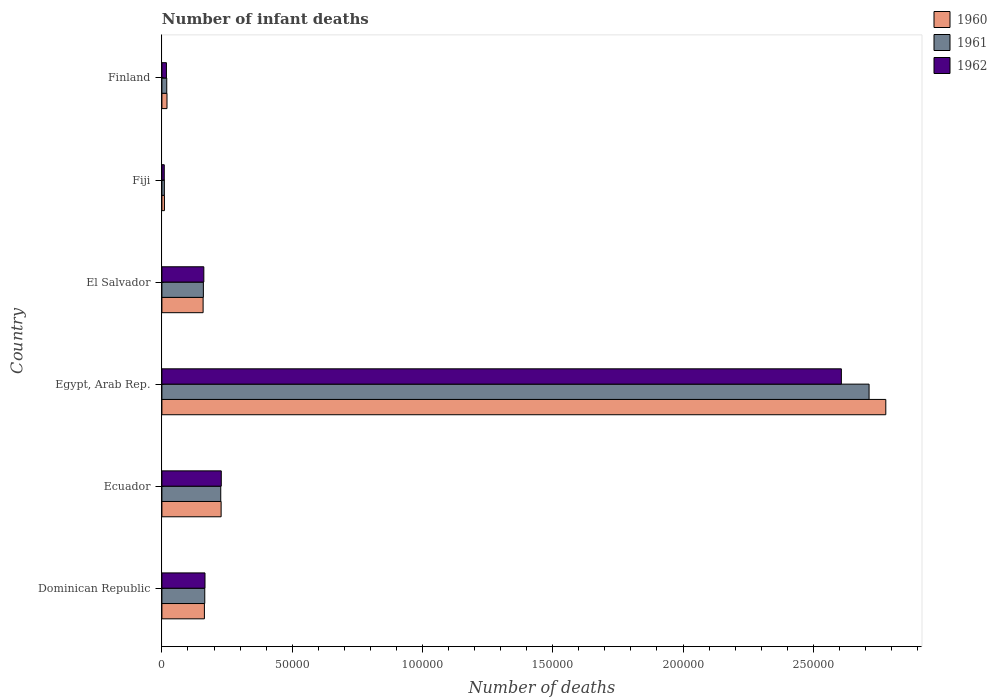How many groups of bars are there?
Provide a succinct answer. 6. Are the number of bars per tick equal to the number of legend labels?
Ensure brevity in your answer.  Yes. Are the number of bars on each tick of the Y-axis equal?
Provide a short and direct response. Yes. In how many cases, is the number of bars for a given country not equal to the number of legend labels?
Offer a very short reply. 0. What is the number of infant deaths in 1962 in El Salvador?
Your answer should be very brief. 1.61e+04. Across all countries, what is the maximum number of infant deaths in 1961?
Offer a terse response. 2.71e+05. Across all countries, what is the minimum number of infant deaths in 1961?
Make the answer very short. 945. In which country was the number of infant deaths in 1962 maximum?
Give a very brief answer. Egypt, Arab Rep. In which country was the number of infant deaths in 1962 minimum?
Make the answer very short. Fiji. What is the total number of infant deaths in 1960 in the graph?
Your answer should be compact. 3.36e+05. What is the difference between the number of infant deaths in 1961 in Ecuador and that in Egypt, Arab Rep.?
Offer a very short reply. -2.49e+05. What is the difference between the number of infant deaths in 1961 in Fiji and the number of infant deaths in 1962 in Finland?
Give a very brief answer. -799. What is the average number of infant deaths in 1962 per country?
Provide a succinct answer. 5.31e+04. What is the difference between the number of infant deaths in 1961 and number of infant deaths in 1960 in Ecuador?
Your answer should be very brief. -143. In how many countries, is the number of infant deaths in 1962 greater than 140000 ?
Make the answer very short. 1. What is the ratio of the number of infant deaths in 1962 in Dominican Republic to that in Fiji?
Offer a very short reply. 18.19. Is the difference between the number of infant deaths in 1961 in Fiji and Finland greater than the difference between the number of infant deaths in 1960 in Fiji and Finland?
Provide a succinct answer. Yes. What is the difference between the highest and the second highest number of infant deaths in 1961?
Provide a short and direct response. 2.49e+05. What is the difference between the highest and the lowest number of infant deaths in 1960?
Provide a short and direct response. 2.77e+05. In how many countries, is the number of infant deaths in 1960 greater than the average number of infant deaths in 1960 taken over all countries?
Your answer should be compact. 1. What does the 3rd bar from the top in Ecuador represents?
Your answer should be compact. 1960. What does the 1st bar from the bottom in Finland represents?
Give a very brief answer. 1960. How many bars are there?
Keep it short and to the point. 18. Are all the bars in the graph horizontal?
Offer a terse response. Yes. How many countries are there in the graph?
Keep it short and to the point. 6. What is the difference between two consecutive major ticks on the X-axis?
Give a very brief answer. 5.00e+04. Does the graph contain any zero values?
Offer a very short reply. No. Does the graph contain grids?
Give a very brief answer. No. How many legend labels are there?
Keep it short and to the point. 3. How are the legend labels stacked?
Ensure brevity in your answer.  Vertical. What is the title of the graph?
Offer a terse response. Number of infant deaths. Does "2004" appear as one of the legend labels in the graph?
Your answer should be very brief. No. What is the label or title of the X-axis?
Give a very brief answer. Number of deaths. What is the Number of deaths of 1960 in Dominican Republic?
Offer a very short reply. 1.63e+04. What is the Number of deaths in 1961 in Dominican Republic?
Your response must be concise. 1.65e+04. What is the Number of deaths of 1962 in Dominican Republic?
Your answer should be compact. 1.65e+04. What is the Number of deaths of 1960 in Ecuador?
Give a very brief answer. 2.27e+04. What is the Number of deaths in 1961 in Ecuador?
Make the answer very short. 2.26e+04. What is the Number of deaths in 1962 in Ecuador?
Ensure brevity in your answer.  2.28e+04. What is the Number of deaths of 1960 in Egypt, Arab Rep.?
Make the answer very short. 2.78e+05. What is the Number of deaths of 1961 in Egypt, Arab Rep.?
Offer a very short reply. 2.71e+05. What is the Number of deaths in 1962 in Egypt, Arab Rep.?
Make the answer very short. 2.61e+05. What is the Number of deaths of 1960 in El Salvador?
Make the answer very short. 1.58e+04. What is the Number of deaths in 1961 in El Salvador?
Ensure brevity in your answer.  1.59e+04. What is the Number of deaths in 1962 in El Salvador?
Offer a terse response. 1.61e+04. What is the Number of deaths of 1960 in Fiji?
Your answer should be very brief. 977. What is the Number of deaths of 1961 in Fiji?
Offer a terse response. 945. What is the Number of deaths of 1962 in Fiji?
Keep it short and to the point. 909. What is the Number of deaths of 1960 in Finland?
Give a very brief answer. 1955. What is the Number of deaths of 1961 in Finland?
Ensure brevity in your answer.  1863. What is the Number of deaths in 1962 in Finland?
Your answer should be very brief. 1744. Across all countries, what is the maximum Number of deaths in 1960?
Ensure brevity in your answer.  2.78e+05. Across all countries, what is the maximum Number of deaths of 1961?
Provide a succinct answer. 2.71e+05. Across all countries, what is the maximum Number of deaths in 1962?
Your response must be concise. 2.61e+05. Across all countries, what is the minimum Number of deaths in 1960?
Make the answer very short. 977. Across all countries, what is the minimum Number of deaths in 1961?
Your answer should be very brief. 945. Across all countries, what is the minimum Number of deaths in 1962?
Offer a very short reply. 909. What is the total Number of deaths in 1960 in the graph?
Your answer should be compact. 3.36e+05. What is the total Number of deaths of 1961 in the graph?
Make the answer very short. 3.29e+05. What is the total Number of deaths in 1962 in the graph?
Provide a short and direct response. 3.19e+05. What is the difference between the Number of deaths in 1960 in Dominican Republic and that in Ecuador?
Your response must be concise. -6416. What is the difference between the Number of deaths in 1961 in Dominican Republic and that in Ecuador?
Your answer should be compact. -6135. What is the difference between the Number of deaths of 1962 in Dominican Republic and that in Ecuador?
Your response must be concise. -6251. What is the difference between the Number of deaths of 1960 in Dominican Republic and that in Egypt, Arab Rep.?
Make the answer very short. -2.62e+05. What is the difference between the Number of deaths of 1961 in Dominican Republic and that in Egypt, Arab Rep.?
Give a very brief answer. -2.55e+05. What is the difference between the Number of deaths of 1962 in Dominican Republic and that in Egypt, Arab Rep.?
Give a very brief answer. -2.44e+05. What is the difference between the Number of deaths of 1960 in Dominican Republic and that in El Salvador?
Make the answer very short. 496. What is the difference between the Number of deaths in 1961 in Dominican Republic and that in El Salvador?
Ensure brevity in your answer.  537. What is the difference between the Number of deaths of 1962 in Dominican Republic and that in El Salvador?
Offer a very short reply. 449. What is the difference between the Number of deaths of 1960 in Dominican Republic and that in Fiji?
Offer a terse response. 1.53e+04. What is the difference between the Number of deaths of 1961 in Dominican Republic and that in Fiji?
Make the answer very short. 1.55e+04. What is the difference between the Number of deaths of 1962 in Dominican Republic and that in Fiji?
Your answer should be very brief. 1.56e+04. What is the difference between the Number of deaths in 1960 in Dominican Republic and that in Finland?
Provide a succinct answer. 1.44e+04. What is the difference between the Number of deaths of 1961 in Dominican Republic and that in Finland?
Offer a very short reply. 1.46e+04. What is the difference between the Number of deaths of 1962 in Dominican Republic and that in Finland?
Your response must be concise. 1.48e+04. What is the difference between the Number of deaths in 1960 in Ecuador and that in Egypt, Arab Rep.?
Give a very brief answer. -2.55e+05. What is the difference between the Number of deaths in 1961 in Ecuador and that in Egypt, Arab Rep.?
Keep it short and to the point. -2.49e+05. What is the difference between the Number of deaths of 1962 in Ecuador and that in Egypt, Arab Rep.?
Your answer should be very brief. -2.38e+05. What is the difference between the Number of deaths in 1960 in Ecuador and that in El Salvador?
Your response must be concise. 6912. What is the difference between the Number of deaths of 1961 in Ecuador and that in El Salvador?
Your answer should be very brief. 6672. What is the difference between the Number of deaths of 1962 in Ecuador and that in El Salvador?
Your response must be concise. 6700. What is the difference between the Number of deaths of 1960 in Ecuador and that in Fiji?
Your answer should be very brief. 2.18e+04. What is the difference between the Number of deaths in 1961 in Ecuador and that in Fiji?
Your response must be concise. 2.16e+04. What is the difference between the Number of deaths in 1962 in Ecuador and that in Fiji?
Give a very brief answer. 2.19e+04. What is the difference between the Number of deaths of 1960 in Ecuador and that in Finland?
Offer a terse response. 2.08e+04. What is the difference between the Number of deaths in 1961 in Ecuador and that in Finland?
Keep it short and to the point. 2.07e+04. What is the difference between the Number of deaths in 1962 in Ecuador and that in Finland?
Give a very brief answer. 2.10e+04. What is the difference between the Number of deaths in 1960 in Egypt, Arab Rep. and that in El Salvador?
Offer a terse response. 2.62e+05. What is the difference between the Number of deaths in 1961 in Egypt, Arab Rep. and that in El Salvador?
Provide a short and direct response. 2.56e+05. What is the difference between the Number of deaths in 1962 in Egypt, Arab Rep. and that in El Salvador?
Your answer should be compact. 2.45e+05. What is the difference between the Number of deaths of 1960 in Egypt, Arab Rep. and that in Fiji?
Provide a short and direct response. 2.77e+05. What is the difference between the Number of deaths in 1961 in Egypt, Arab Rep. and that in Fiji?
Make the answer very short. 2.70e+05. What is the difference between the Number of deaths in 1962 in Egypt, Arab Rep. and that in Fiji?
Give a very brief answer. 2.60e+05. What is the difference between the Number of deaths of 1960 in Egypt, Arab Rep. and that in Finland?
Keep it short and to the point. 2.76e+05. What is the difference between the Number of deaths of 1961 in Egypt, Arab Rep. and that in Finland?
Your answer should be compact. 2.70e+05. What is the difference between the Number of deaths of 1962 in Egypt, Arab Rep. and that in Finland?
Offer a very short reply. 2.59e+05. What is the difference between the Number of deaths of 1960 in El Salvador and that in Fiji?
Keep it short and to the point. 1.48e+04. What is the difference between the Number of deaths in 1961 in El Salvador and that in Fiji?
Provide a succinct answer. 1.50e+04. What is the difference between the Number of deaths of 1962 in El Salvador and that in Fiji?
Your answer should be compact. 1.52e+04. What is the difference between the Number of deaths of 1960 in El Salvador and that in Finland?
Offer a very short reply. 1.39e+04. What is the difference between the Number of deaths of 1961 in El Salvador and that in Finland?
Provide a short and direct response. 1.41e+04. What is the difference between the Number of deaths in 1962 in El Salvador and that in Finland?
Your answer should be very brief. 1.43e+04. What is the difference between the Number of deaths of 1960 in Fiji and that in Finland?
Keep it short and to the point. -978. What is the difference between the Number of deaths in 1961 in Fiji and that in Finland?
Your answer should be very brief. -918. What is the difference between the Number of deaths of 1962 in Fiji and that in Finland?
Your response must be concise. -835. What is the difference between the Number of deaths of 1960 in Dominican Republic and the Number of deaths of 1961 in Ecuador?
Make the answer very short. -6273. What is the difference between the Number of deaths in 1960 in Dominican Republic and the Number of deaths in 1962 in Ecuador?
Offer a very short reply. -6475. What is the difference between the Number of deaths in 1961 in Dominican Republic and the Number of deaths in 1962 in Ecuador?
Ensure brevity in your answer.  -6337. What is the difference between the Number of deaths of 1960 in Dominican Republic and the Number of deaths of 1961 in Egypt, Arab Rep.?
Your response must be concise. -2.55e+05. What is the difference between the Number of deaths of 1960 in Dominican Republic and the Number of deaths of 1962 in Egypt, Arab Rep.?
Offer a terse response. -2.44e+05. What is the difference between the Number of deaths in 1961 in Dominican Republic and the Number of deaths in 1962 in Egypt, Arab Rep.?
Offer a very short reply. -2.44e+05. What is the difference between the Number of deaths of 1960 in Dominican Republic and the Number of deaths of 1961 in El Salvador?
Make the answer very short. 399. What is the difference between the Number of deaths of 1960 in Dominican Republic and the Number of deaths of 1962 in El Salvador?
Your answer should be compact. 225. What is the difference between the Number of deaths in 1961 in Dominican Republic and the Number of deaths in 1962 in El Salvador?
Give a very brief answer. 363. What is the difference between the Number of deaths in 1960 in Dominican Republic and the Number of deaths in 1961 in Fiji?
Give a very brief answer. 1.54e+04. What is the difference between the Number of deaths of 1960 in Dominican Republic and the Number of deaths of 1962 in Fiji?
Offer a terse response. 1.54e+04. What is the difference between the Number of deaths in 1961 in Dominican Republic and the Number of deaths in 1962 in Fiji?
Ensure brevity in your answer.  1.55e+04. What is the difference between the Number of deaths of 1960 in Dominican Republic and the Number of deaths of 1961 in Finland?
Your answer should be very brief. 1.45e+04. What is the difference between the Number of deaths in 1960 in Dominican Republic and the Number of deaths in 1962 in Finland?
Make the answer very short. 1.46e+04. What is the difference between the Number of deaths in 1961 in Dominican Republic and the Number of deaths in 1962 in Finland?
Make the answer very short. 1.47e+04. What is the difference between the Number of deaths in 1960 in Ecuador and the Number of deaths in 1961 in Egypt, Arab Rep.?
Your answer should be very brief. -2.49e+05. What is the difference between the Number of deaths of 1960 in Ecuador and the Number of deaths of 1962 in Egypt, Arab Rep.?
Your response must be concise. -2.38e+05. What is the difference between the Number of deaths in 1961 in Ecuador and the Number of deaths in 1962 in Egypt, Arab Rep.?
Make the answer very short. -2.38e+05. What is the difference between the Number of deaths of 1960 in Ecuador and the Number of deaths of 1961 in El Salvador?
Offer a very short reply. 6815. What is the difference between the Number of deaths of 1960 in Ecuador and the Number of deaths of 1962 in El Salvador?
Provide a succinct answer. 6641. What is the difference between the Number of deaths of 1961 in Ecuador and the Number of deaths of 1962 in El Salvador?
Your answer should be very brief. 6498. What is the difference between the Number of deaths of 1960 in Ecuador and the Number of deaths of 1961 in Fiji?
Offer a terse response. 2.18e+04. What is the difference between the Number of deaths in 1960 in Ecuador and the Number of deaths in 1962 in Fiji?
Give a very brief answer. 2.18e+04. What is the difference between the Number of deaths of 1961 in Ecuador and the Number of deaths of 1962 in Fiji?
Keep it short and to the point. 2.17e+04. What is the difference between the Number of deaths of 1960 in Ecuador and the Number of deaths of 1961 in Finland?
Ensure brevity in your answer.  2.09e+04. What is the difference between the Number of deaths of 1960 in Ecuador and the Number of deaths of 1962 in Finland?
Give a very brief answer. 2.10e+04. What is the difference between the Number of deaths of 1961 in Ecuador and the Number of deaths of 1962 in Finland?
Make the answer very short. 2.08e+04. What is the difference between the Number of deaths of 1960 in Egypt, Arab Rep. and the Number of deaths of 1961 in El Salvador?
Make the answer very short. 2.62e+05. What is the difference between the Number of deaths in 1960 in Egypt, Arab Rep. and the Number of deaths in 1962 in El Salvador?
Your answer should be very brief. 2.62e+05. What is the difference between the Number of deaths in 1961 in Egypt, Arab Rep. and the Number of deaths in 1962 in El Salvador?
Offer a very short reply. 2.55e+05. What is the difference between the Number of deaths of 1960 in Egypt, Arab Rep. and the Number of deaths of 1961 in Fiji?
Make the answer very short. 2.77e+05. What is the difference between the Number of deaths in 1960 in Egypt, Arab Rep. and the Number of deaths in 1962 in Fiji?
Offer a very short reply. 2.77e+05. What is the difference between the Number of deaths of 1961 in Egypt, Arab Rep. and the Number of deaths of 1962 in Fiji?
Offer a very short reply. 2.71e+05. What is the difference between the Number of deaths in 1960 in Egypt, Arab Rep. and the Number of deaths in 1961 in Finland?
Give a very brief answer. 2.76e+05. What is the difference between the Number of deaths of 1960 in Egypt, Arab Rep. and the Number of deaths of 1962 in Finland?
Offer a terse response. 2.76e+05. What is the difference between the Number of deaths in 1961 in Egypt, Arab Rep. and the Number of deaths in 1962 in Finland?
Make the answer very short. 2.70e+05. What is the difference between the Number of deaths of 1960 in El Salvador and the Number of deaths of 1961 in Fiji?
Keep it short and to the point. 1.49e+04. What is the difference between the Number of deaths of 1960 in El Salvador and the Number of deaths of 1962 in Fiji?
Provide a succinct answer. 1.49e+04. What is the difference between the Number of deaths of 1961 in El Salvador and the Number of deaths of 1962 in Fiji?
Your answer should be compact. 1.50e+04. What is the difference between the Number of deaths of 1960 in El Salvador and the Number of deaths of 1961 in Finland?
Ensure brevity in your answer.  1.40e+04. What is the difference between the Number of deaths of 1960 in El Salvador and the Number of deaths of 1962 in Finland?
Your answer should be very brief. 1.41e+04. What is the difference between the Number of deaths in 1961 in El Salvador and the Number of deaths in 1962 in Finland?
Your answer should be compact. 1.42e+04. What is the difference between the Number of deaths in 1960 in Fiji and the Number of deaths in 1961 in Finland?
Offer a very short reply. -886. What is the difference between the Number of deaths of 1960 in Fiji and the Number of deaths of 1962 in Finland?
Ensure brevity in your answer.  -767. What is the difference between the Number of deaths in 1961 in Fiji and the Number of deaths in 1962 in Finland?
Give a very brief answer. -799. What is the average Number of deaths in 1960 per country?
Your answer should be very brief. 5.59e+04. What is the average Number of deaths of 1961 per country?
Provide a short and direct response. 5.49e+04. What is the average Number of deaths of 1962 per country?
Provide a succinct answer. 5.31e+04. What is the difference between the Number of deaths in 1960 and Number of deaths in 1961 in Dominican Republic?
Ensure brevity in your answer.  -138. What is the difference between the Number of deaths of 1960 and Number of deaths of 1962 in Dominican Republic?
Offer a terse response. -224. What is the difference between the Number of deaths of 1961 and Number of deaths of 1962 in Dominican Republic?
Give a very brief answer. -86. What is the difference between the Number of deaths of 1960 and Number of deaths of 1961 in Ecuador?
Offer a terse response. 143. What is the difference between the Number of deaths in 1960 and Number of deaths in 1962 in Ecuador?
Offer a very short reply. -59. What is the difference between the Number of deaths of 1961 and Number of deaths of 1962 in Ecuador?
Make the answer very short. -202. What is the difference between the Number of deaths in 1960 and Number of deaths in 1961 in Egypt, Arab Rep.?
Your answer should be compact. 6414. What is the difference between the Number of deaths in 1960 and Number of deaths in 1962 in Egypt, Arab Rep.?
Your answer should be compact. 1.70e+04. What is the difference between the Number of deaths in 1961 and Number of deaths in 1962 in Egypt, Arab Rep.?
Ensure brevity in your answer.  1.06e+04. What is the difference between the Number of deaths of 1960 and Number of deaths of 1961 in El Salvador?
Your response must be concise. -97. What is the difference between the Number of deaths in 1960 and Number of deaths in 1962 in El Salvador?
Offer a terse response. -271. What is the difference between the Number of deaths of 1961 and Number of deaths of 1962 in El Salvador?
Your response must be concise. -174. What is the difference between the Number of deaths in 1960 and Number of deaths in 1962 in Fiji?
Make the answer very short. 68. What is the difference between the Number of deaths in 1961 and Number of deaths in 1962 in Fiji?
Offer a terse response. 36. What is the difference between the Number of deaths of 1960 and Number of deaths of 1961 in Finland?
Give a very brief answer. 92. What is the difference between the Number of deaths of 1960 and Number of deaths of 1962 in Finland?
Your response must be concise. 211. What is the difference between the Number of deaths of 1961 and Number of deaths of 1962 in Finland?
Make the answer very short. 119. What is the ratio of the Number of deaths of 1960 in Dominican Republic to that in Ecuador?
Your answer should be very brief. 0.72. What is the ratio of the Number of deaths of 1961 in Dominican Republic to that in Ecuador?
Provide a succinct answer. 0.73. What is the ratio of the Number of deaths in 1962 in Dominican Republic to that in Ecuador?
Your answer should be very brief. 0.73. What is the ratio of the Number of deaths in 1960 in Dominican Republic to that in Egypt, Arab Rep.?
Offer a terse response. 0.06. What is the ratio of the Number of deaths of 1961 in Dominican Republic to that in Egypt, Arab Rep.?
Your answer should be compact. 0.06. What is the ratio of the Number of deaths of 1962 in Dominican Republic to that in Egypt, Arab Rep.?
Offer a terse response. 0.06. What is the ratio of the Number of deaths of 1960 in Dominican Republic to that in El Salvador?
Your answer should be compact. 1.03. What is the ratio of the Number of deaths of 1961 in Dominican Republic to that in El Salvador?
Provide a short and direct response. 1.03. What is the ratio of the Number of deaths of 1962 in Dominican Republic to that in El Salvador?
Offer a very short reply. 1.03. What is the ratio of the Number of deaths of 1960 in Dominican Republic to that in Fiji?
Ensure brevity in your answer.  16.7. What is the ratio of the Number of deaths of 1961 in Dominican Republic to that in Fiji?
Make the answer very short. 17.41. What is the ratio of the Number of deaths in 1962 in Dominican Republic to that in Fiji?
Provide a short and direct response. 18.19. What is the ratio of the Number of deaths in 1960 in Dominican Republic to that in Finland?
Provide a short and direct response. 8.35. What is the ratio of the Number of deaths of 1961 in Dominican Republic to that in Finland?
Give a very brief answer. 8.83. What is the ratio of the Number of deaths in 1962 in Dominican Republic to that in Finland?
Ensure brevity in your answer.  9.48. What is the ratio of the Number of deaths in 1960 in Ecuador to that in Egypt, Arab Rep.?
Offer a terse response. 0.08. What is the ratio of the Number of deaths of 1961 in Ecuador to that in Egypt, Arab Rep.?
Provide a short and direct response. 0.08. What is the ratio of the Number of deaths in 1962 in Ecuador to that in Egypt, Arab Rep.?
Your answer should be very brief. 0.09. What is the ratio of the Number of deaths of 1960 in Ecuador to that in El Salvador?
Your answer should be compact. 1.44. What is the ratio of the Number of deaths in 1961 in Ecuador to that in El Salvador?
Provide a succinct answer. 1.42. What is the ratio of the Number of deaths in 1962 in Ecuador to that in El Salvador?
Your answer should be very brief. 1.42. What is the ratio of the Number of deaths of 1960 in Ecuador to that in Fiji?
Your answer should be very brief. 23.27. What is the ratio of the Number of deaths in 1961 in Ecuador to that in Fiji?
Provide a succinct answer. 23.9. What is the ratio of the Number of deaths of 1962 in Ecuador to that in Fiji?
Your answer should be very brief. 25.07. What is the ratio of the Number of deaths in 1960 in Ecuador to that in Finland?
Keep it short and to the point. 11.63. What is the ratio of the Number of deaths of 1961 in Ecuador to that in Finland?
Provide a succinct answer. 12.12. What is the ratio of the Number of deaths of 1962 in Ecuador to that in Finland?
Your answer should be very brief. 13.07. What is the ratio of the Number of deaths in 1960 in Egypt, Arab Rep. to that in El Salvador?
Your response must be concise. 17.56. What is the ratio of the Number of deaths of 1961 in Egypt, Arab Rep. to that in El Salvador?
Your response must be concise. 17.05. What is the ratio of the Number of deaths in 1962 in Egypt, Arab Rep. to that in El Salvador?
Your response must be concise. 16.21. What is the ratio of the Number of deaths of 1960 in Egypt, Arab Rep. to that in Fiji?
Keep it short and to the point. 284.38. What is the ratio of the Number of deaths of 1961 in Egypt, Arab Rep. to that in Fiji?
Your response must be concise. 287.22. What is the ratio of the Number of deaths in 1962 in Egypt, Arab Rep. to that in Fiji?
Offer a terse response. 286.9. What is the ratio of the Number of deaths in 1960 in Egypt, Arab Rep. to that in Finland?
Your response must be concise. 142.12. What is the ratio of the Number of deaths in 1961 in Egypt, Arab Rep. to that in Finland?
Ensure brevity in your answer.  145.69. What is the ratio of the Number of deaths in 1962 in Egypt, Arab Rep. to that in Finland?
Provide a short and direct response. 149.53. What is the ratio of the Number of deaths in 1960 in El Salvador to that in Fiji?
Keep it short and to the point. 16.19. What is the ratio of the Number of deaths of 1961 in El Salvador to that in Fiji?
Offer a very short reply. 16.84. What is the ratio of the Number of deaths of 1962 in El Salvador to that in Fiji?
Offer a terse response. 17.7. What is the ratio of the Number of deaths of 1960 in El Salvador to that in Finland?
Offer a very short reply. 8.09. What is the ratio of the Number of deaths of 1961 in El Salvador to that in Finland?
Offer a very short reply. 8.54. What is the ratio of the Number of deaths of 1962 in El Salvador to that in Finland?
Your response must be concise. 9.23. What is the ratio of the Number of deaths in 1960 in Fiji to that in Finland?
Ensure brevity in your answer.  0.5. What is the ratio of the Number of deaths of 1961 in Fiji to that in Finland?
Give a very brief answer. 0.51. What is the ratio of the Number of deaths in 1962 in Fiji to that in Finland?
Provide a short and direct response. 0.52. What is the difference between the highest and the second highest Number of deaths in 1960?
Your answer should be very brief. 2.55e+05. What is the difference between the highest and the second highest Number of deaths of 1961?
Offer a terse response. 2.49e+05. What is the difference between the highest and the second highest Number of deaths in 1962?
Provide a succinct answer. 2.38e+05. What is the difference between the highest and the lowest Number of deaths of 1960?
Provide a succinct answer. 2.77e+05. What is the difference between the highest and the lowest Number of deaths of 1961?
Your response must be concise. 2.70e+05. What is the difference between the highest and the lowest Number of deaths in 1962?
Ensure brevity in your answer.  2.60e+05. 